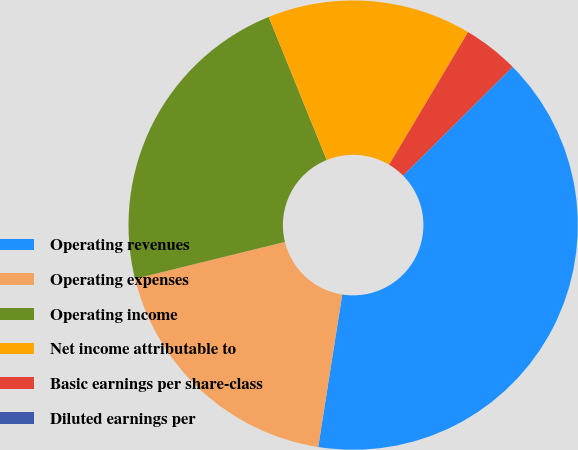<chart> <loc_0><loc_0><loc_500><loc_500><pie_chart><fcel>Operating revenues<fcel>Operating expenses<fcel>Operating income<fcel>Net income attributable to<fcel>Basic earnings per share-class<fcel>Diluted earnings per<nl><fcel>39.91%<fcel>18.67%<fcel>22.71%<fcel>14.68%<fcel>4.01%<fcel>0.02%<nl></chart> 